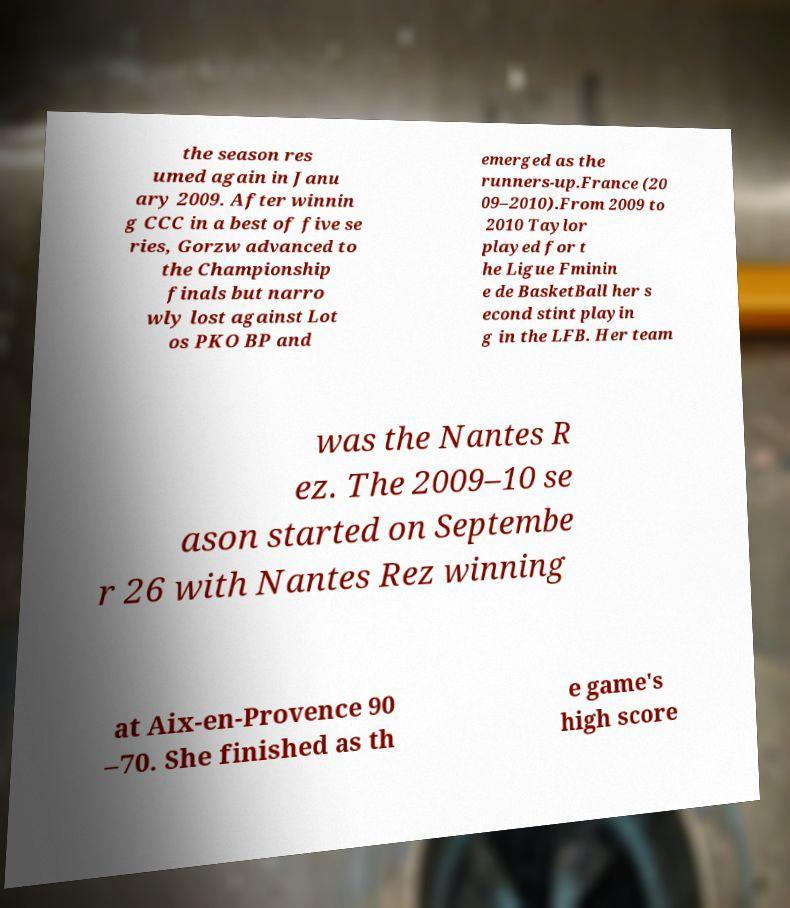There's text embedded in this image that I need extracted. Can you transcribe it verbatim? the season res umed again in Janu ary 2009. After winnin g CCC in a best of five se ries, Gorzw advanced to the Championship finals but narro wly lost against Lot os PKO BP and emerged as the runners-up.France (20 09–2010).From 2009 to 2010 Taylor played for t he Ligue Fminin e de BasketBall her s econd stint playin g in the LFB. Her team was the Nantes R ez. The 2009–10 se ason started on Septembe r 26 with Nantes Rez winning at Aix-en-Provence 90 –70. She finished as th e game's high score 